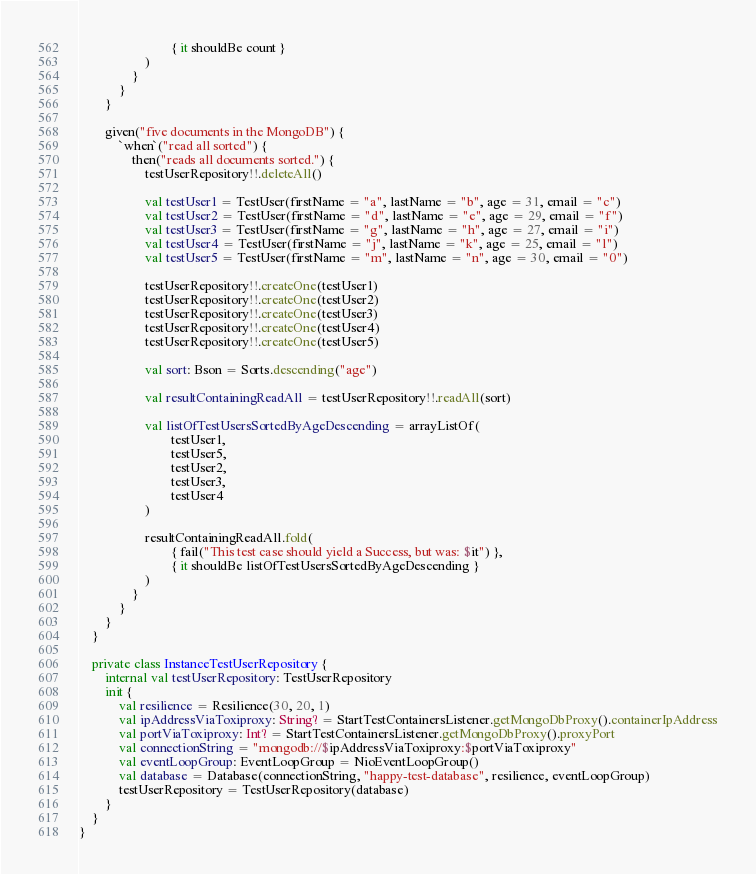<code> <loc_0><loc_0><loc_500><loc_500><_Kotlin_>							{ it shouldBe count }
					)
				}
			}
		}

		given("five documents in the MongoDB") {
			`when`("read all sorted") {
				then("reads all documents sorted.") {
					testUserRepository!!.deleteAll()

					val testUser1 = TestUser(firstName = "a", lastName = "b", age = 31, email = "c")
					val testUser2 = TestUser(firstName = "d", lastName = "e", age = 29, email = "f")
					val testUser3 = TestUser(firstName = "g", lastName = "h", age = 27, email = "i")
					val testUser4 = TestUser(firstName = "j", lastName = "k", age = 25, email = "l")
					val testUser5 = TestUser(firstName = "m", lastName = "n", age = 30, email = "0")

					testUserRepository!!.createOne(testUser1)
					testUserRepository!!.createOne(testUser2)
					testUserRepository!!.createOne(testUser3)
					testUserRepository!!.createOne(testUser4)
					testUserRepository!!.createOne(testUser5)

					val sort: Bson = Sorts.descending("age")

					val resultContainingReadAll = testUserRepository!!.readAll(sort)

					val listOfTestUsersSortedByAgeDescending = arrayListOf(
							testUser1,
							testUser5,
							testUser2,
							testUser3,
							testUser4
					)

					resultContainingReadAll.fold(
							{ fail("This test case should yield a Success, but was: $it") },
							{ it shouldBe listOfTestUsersSortedByAgeDescending }
					)
				}
			}
		}
	}

	private class InstanceTestUserRepository {
		internal val testUserRepository: TestUserRepository
		init {
			val resilience = Resilience(30, 20, 1)
			val ipAddressViaToxiproxy: String? = StartTestContainersListener.getMongoDbProxy().containerIpAddress
			val portViaToxiproxy: Int? = StartTestContainersListener.getMongoDbProxy().proxyPort
			val connectionString = "mongodb://$ipAddressViaToxiproxy:$portViaToxiproxy"
			val eventLoopGroup: EventLoopGroup = NioEventLoopGroup()
			val database = Database(connectionString, "happy-test-database", resilience, eventLoopGroup)
			testUserRepository = TestUserRepository(database)
		}
	}
}
</code> 